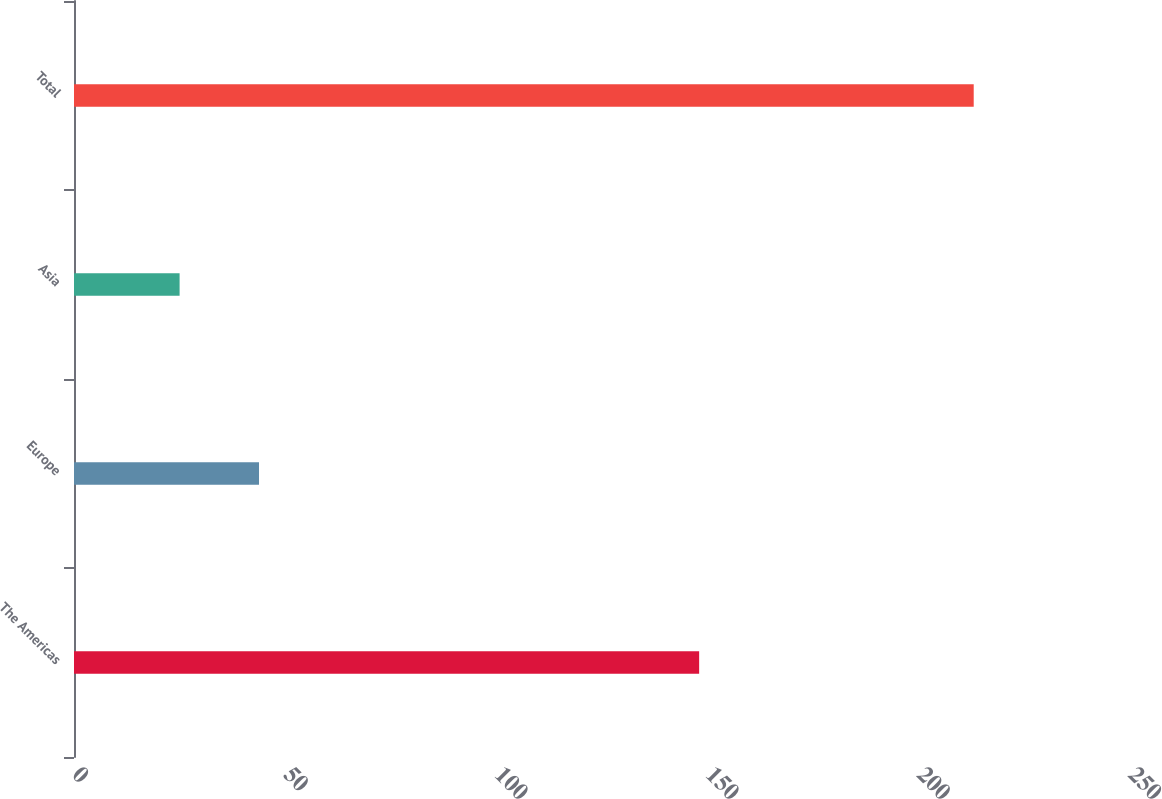Convert chart. <chart><loc_0><loc_0><loc_500><loc_500><bar_chart><fcel>The Americas<fcel>Europe<fcel>Asia<fcel>Total<nl><fcel>148<fcel>43.8<fcel>25<fcel>213<nl></chart> 